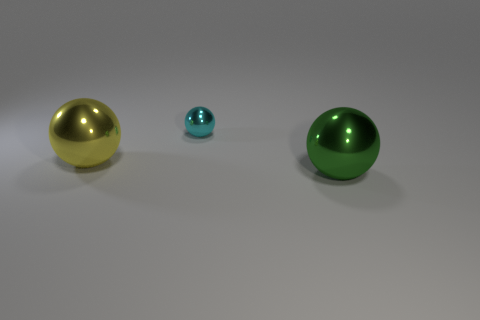Subtract all big metallic balls. How many balls are left? 1 Add 2 large green metallic spheres. How many objects exist? 5 Subtract 0 blue blocks. How many objects are left? 3 Subtract 2 spheres. How many spheres are left? 1 Subtract all gray balls. Subtract all gray blocks. How many balls are left? 3 Subtract all tiny spheres. Subtract all green metallic things. How many objects are left? 1 Add 2 spheres. How many spheres are left? 5 Add 1 large green balls. How many large green balls exist? 2 